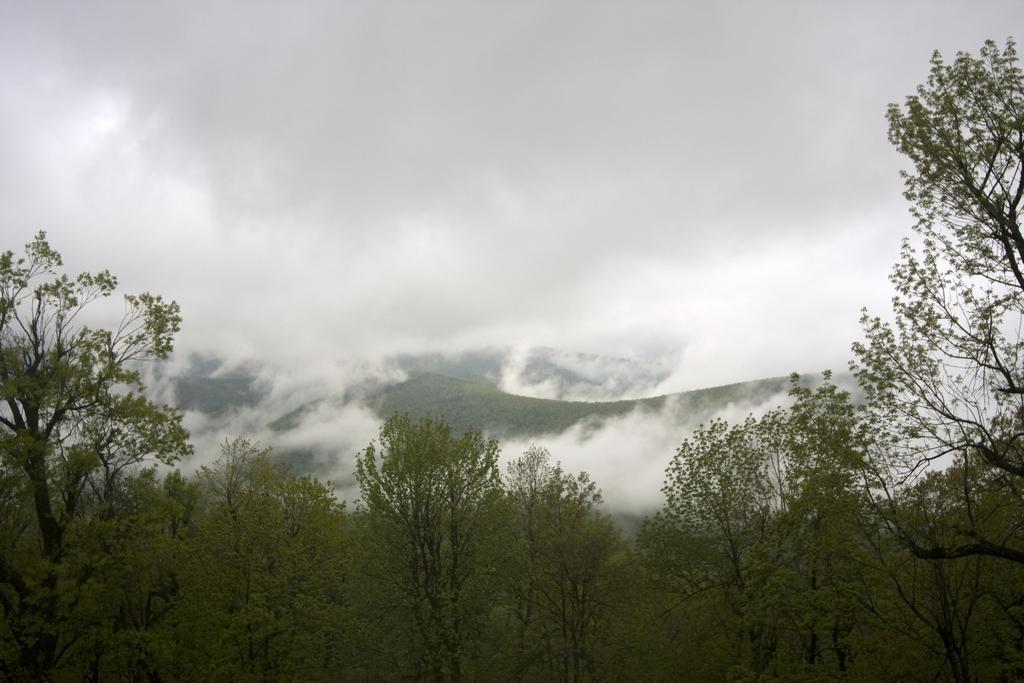What type of vegetation is at the bottom of the image? There are trees at the bottom of the image. What geographical features are in the middle of the image? There are hills in the middle of the image. What atmospheric condition is present in the image? Fog is present in the image. What part of the natural environment is visible in the image? The sky is visible in the image. What type of door can be seen in the image? There is no door present in the image. How is the corn distributed in the image? There is no corn present in the image. 